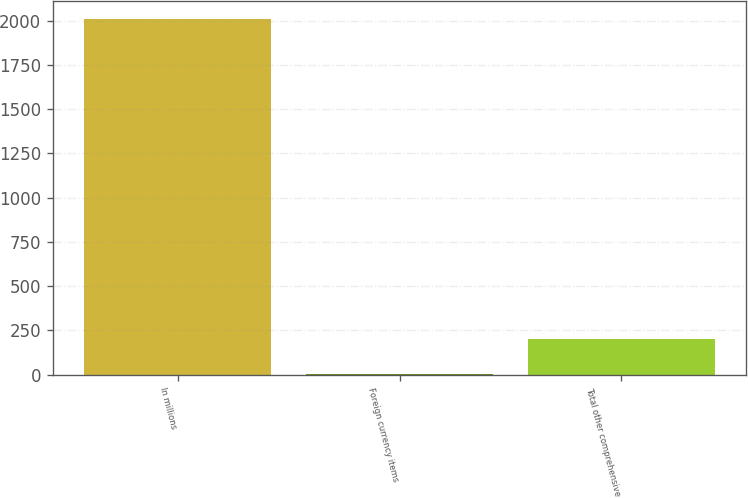<chart> <loc_0><loc_0><loc_500><loc_500><bar_chart><fcel>In millions<fcel>Foreign currency items<fcel>Total other comprehensive<nl><fcel>2013<fcel>0.8<fcel>202.02<nl></chart> 